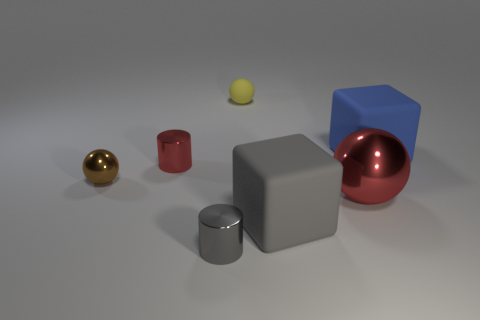Subtract 1 cylinders. How many cylinders are left? 1 Subtract all blue balls. Subtract all cyan cubes. How many balls are left? 3 Add 2 gray metallic cylinders. How many objects exist? 9 Subtract all cylinders. How many objects are left? 5 Add 3 small cyan matte blocks. How many small cyan matte blocks exist? 3 Subtract 0 cyan blocks. How many objects are left? 7 Subtract all gray cylinders. Subtract all small objects. How many objects are left? 2 Add 2 tiny gray cylinders. How many tiny gray cylinders are left? 3 